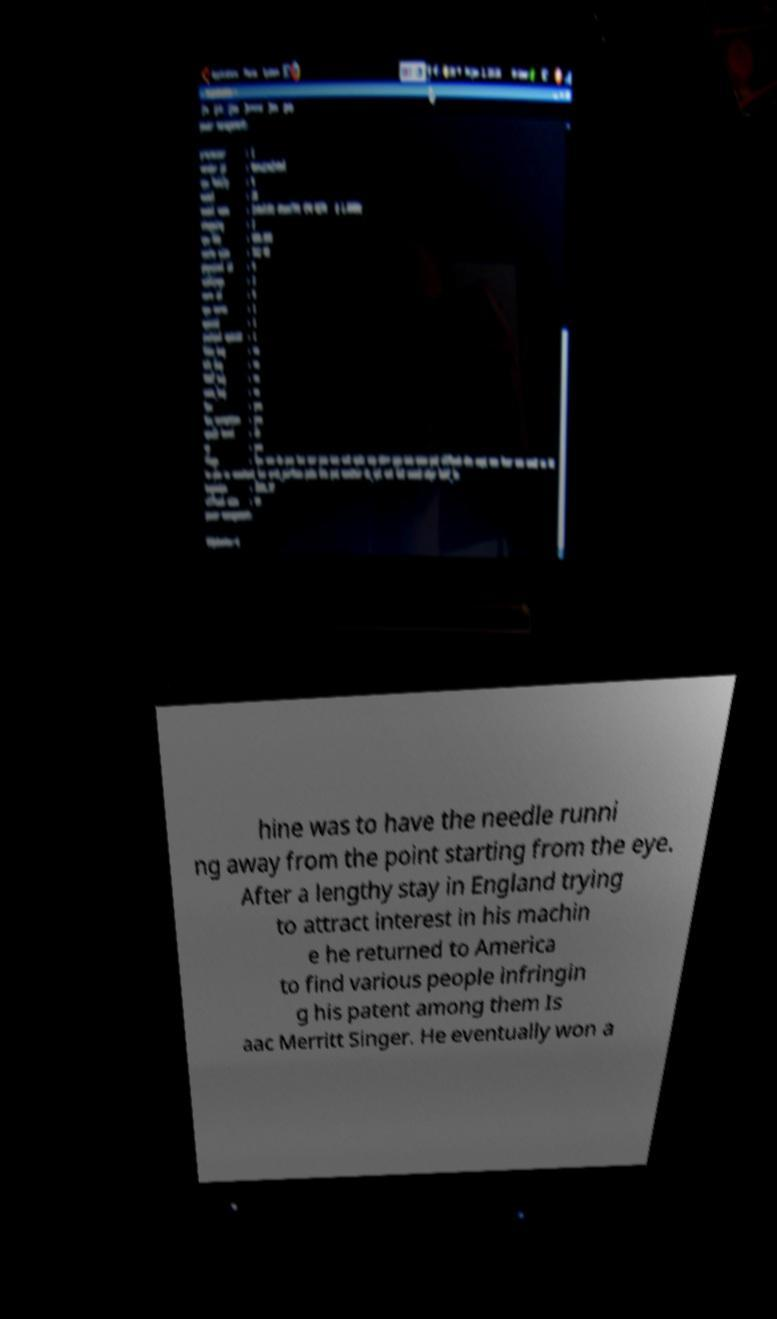I need the written content from this picture converted into text. Can you do that? hine was to have the needle runni ng away from the point starting from the eye. After a lengthy stay in England trying to attract interest in his machin e he returned to America to find various people infringin g his patent among them Is aac Merritt Singer. He eventually won a 